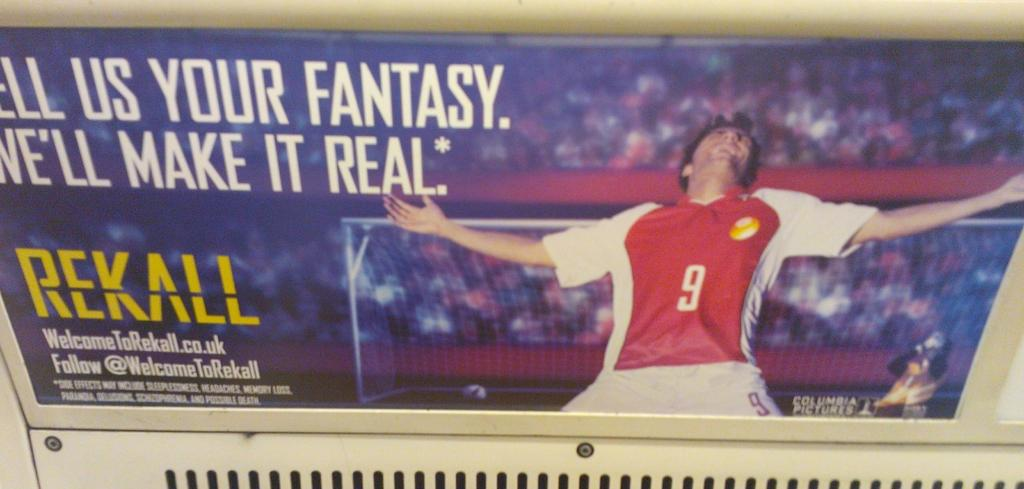<image>
Summarize the visual content of the image. A man with a red and white jersey on with the number 9 with his arms outstretched on a poster. 